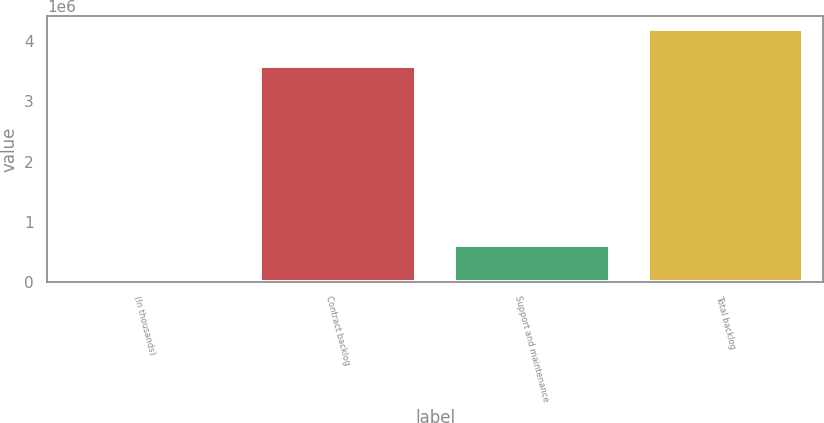Convert chart. <chart><loc_0><loc_0><loc_500><loc_500><bar_chart><fcel>(In thousands)<fcel>Contract backlog<fcel>Support and maintenance<fcel>Total backlog<nl><fcel>2009<fcel>3.59103e+06<fcel>620616<fcel>4.21164e+06<nl></chart> 